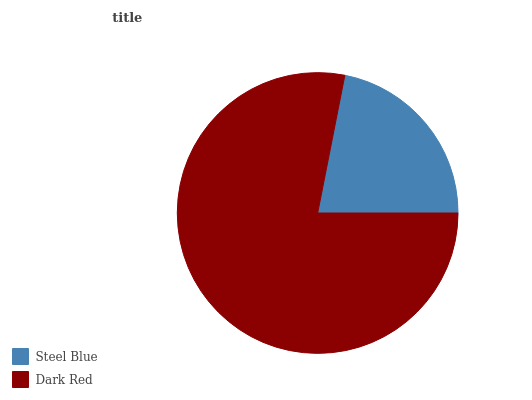Is Steel Blue the minimum?
Answer yes or no. Yes. Is Dark Red the maximum?
Answer yes or no. Yes. Is Dark Red the minimum?
Answer yes or no. No. Is Dark Red greater than Steel Blue?
Answer yes or no. Yes. Is Steel Blue less than Dark Red?
Answer yes or no. Yes. Is Steel Blue greater than Dark Red?
Answer yes or no. No. Is Dark Red less than Steel Blue?
Answer yes or no. No. Is Dark Red the high median?
Answer yes or no. Yes. Is Steel Blue the low median?
Answer yes or no. Yes. Is Steel Blue the high median?
Answer yes or no. No. Is Dark Red the low median?
Answer yes or no. No. 